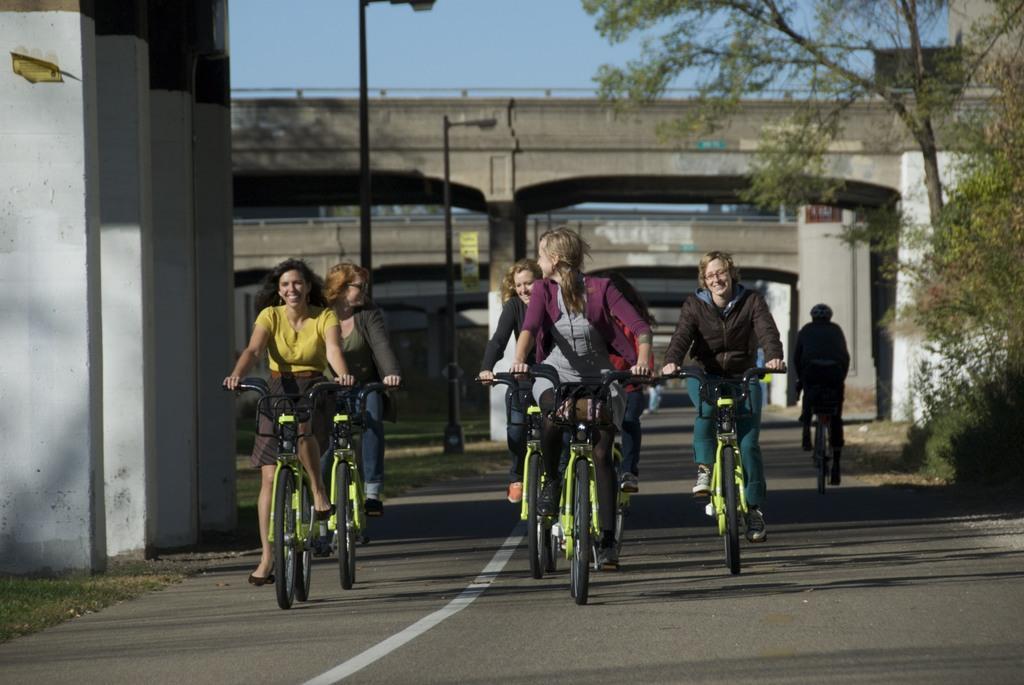In one or two sentences, can you explain what this image depicts? A group of girls riding bicycles on a road. Beside them there are four pillars. At a distance there are two street lights. At the back there are few bridges. At other side there is a tree and plants. 